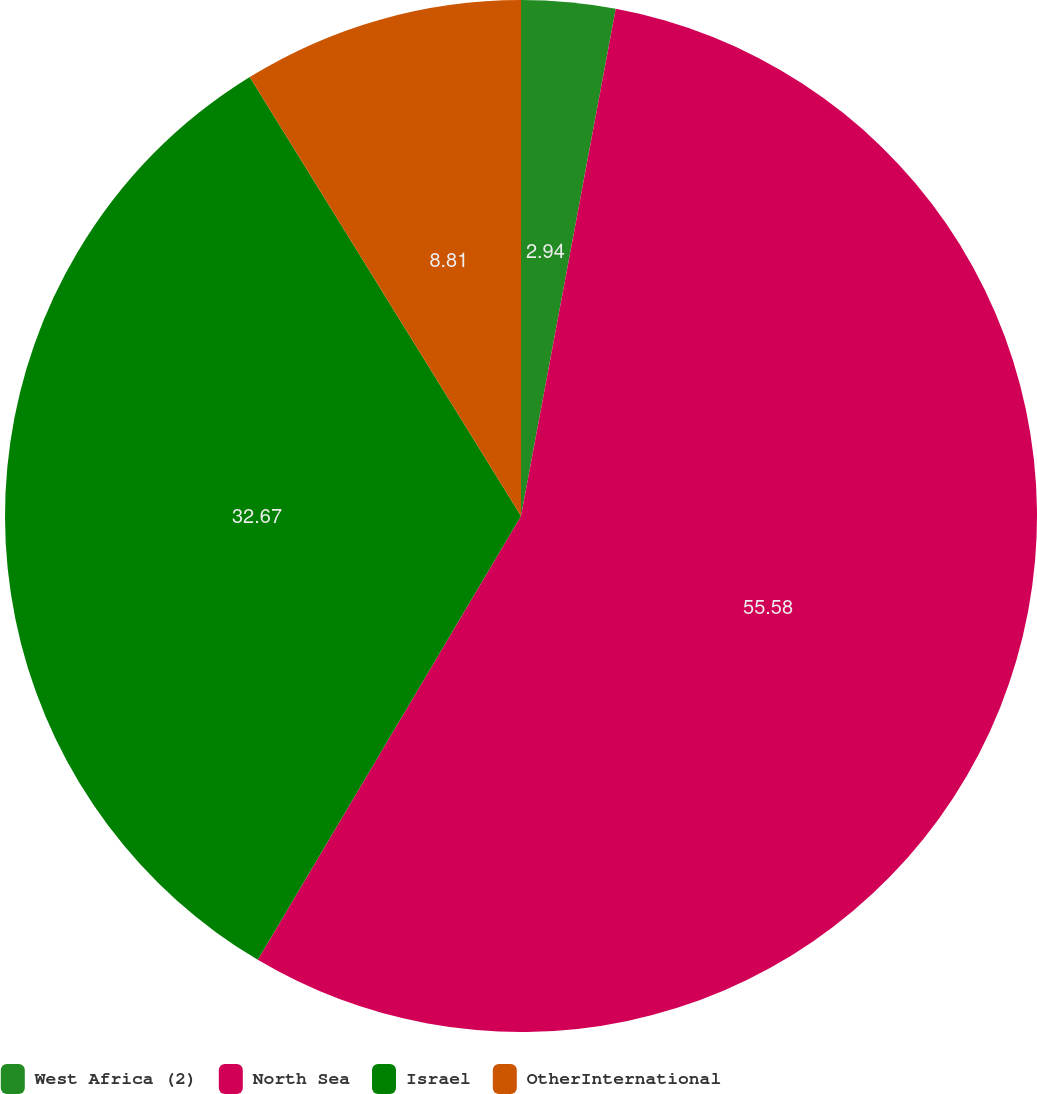Convert chart to OTSL. <chart><loc_0><loc_0><loc_500><loc_500><pie_chart><fcel>West Africa (2)<fcel>North Sea<fcel>Israel<fcel>OtherInternational<nl><fcel>2.94%<fcel>55.58%<fcel>32.67%<fcel>8.81%<nl></chart> 